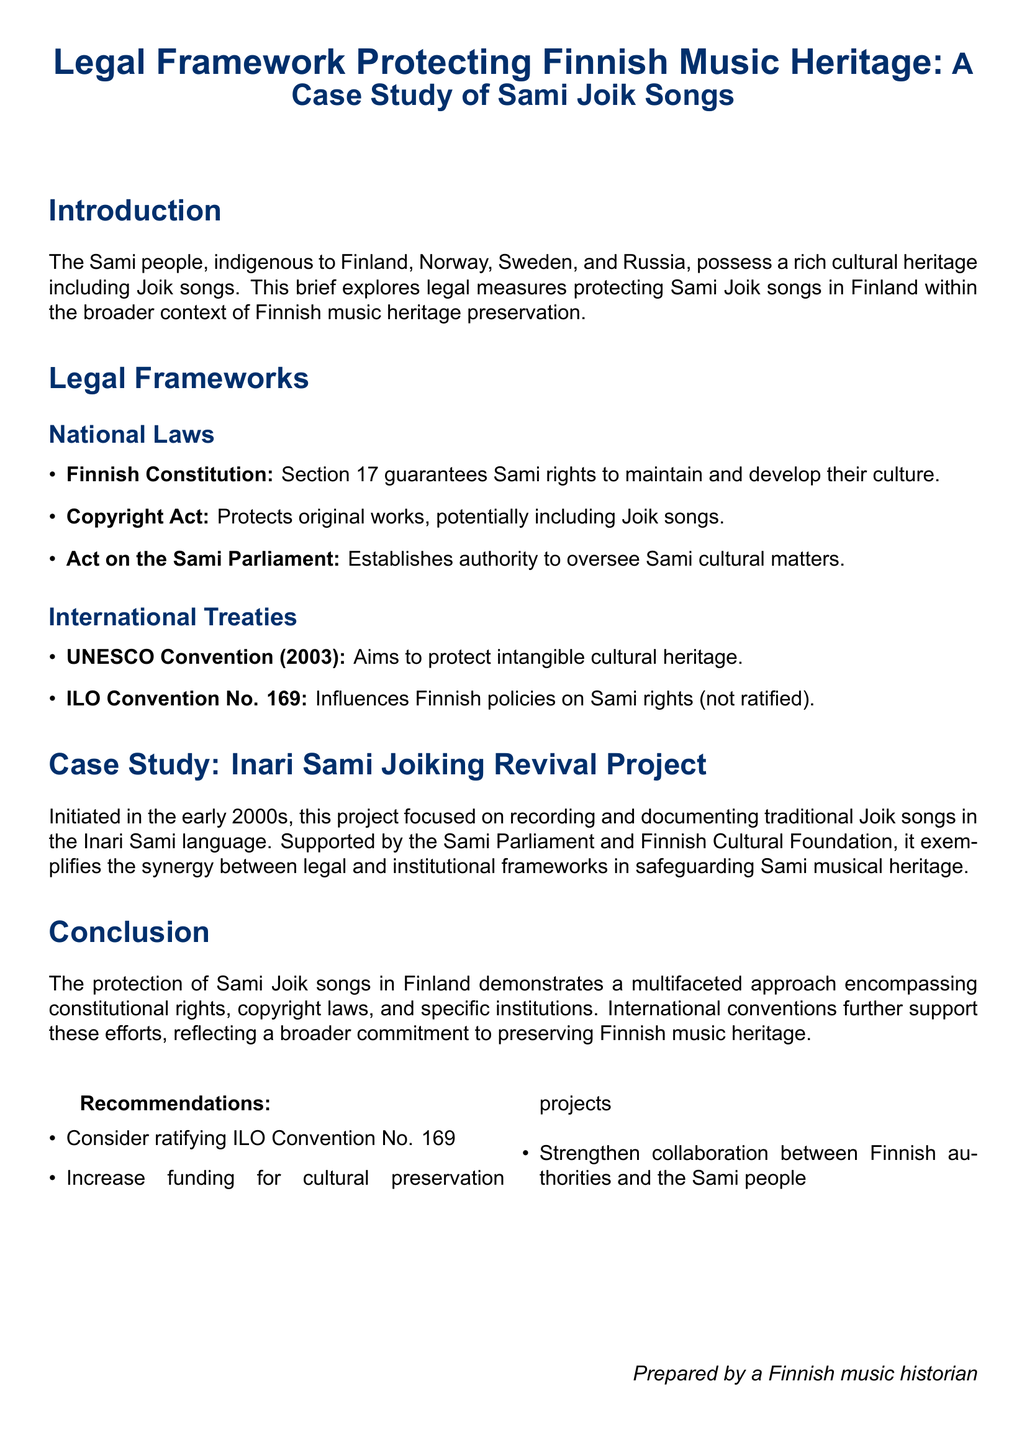What section of the Finnish Constitution guarantees Sami rights? The Finnish Constitution, Section 17, guarantees the Sami rights to maintain and develop their culture.
Answer: Section 17 What is the primary focus of the Inari Sami Joiking Revival Project? The Inari Sami Joiking Revival Project primarily focused on recording and documenting traditional Joik songs in the Inari Sami language.
Answer: Recording and documenting traditional Joik songs Which international treaty aims to protect intangible cultural heritage? The UNESCO Convention (2003) aims to protect intangible cultural heritage.
Answer: UNESCO Convention (2003) What legal act establishes authority to oversee Sami cultural matters? The Act on the Sami Parliament establishes authority to oversee Sami cultural matters.
Answer: Act on the Sami Parliament How many recommendations are provided in the document? The document lists three recommendations for cultural preservation projects.
Answer: Three What year did the Inari Sami Joiking Revival Project begin? The Inari Sami Joiking Revival Project was initiated in the early 2000s.
Answer: Early 2000s What is one recommendation made in the document? The document recommends increasing funding for cultural preservation projects to better protect Finnish music heritage.
Answer: Increase funding for cultural preservation projects Which organization supported the Inari Sami Joiking Revival Project? The project was supported by the Sami Parliament and Finnish Cultural Foundation.
Answer: Sami Parliament and Finnish Cultural Foundation 